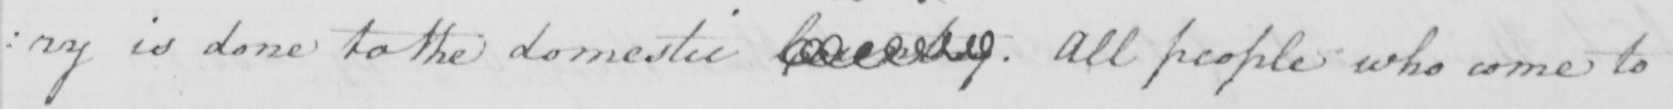Can you tell me what this handwritten text says? : ry is done to the domestic Country  . All people who come to 